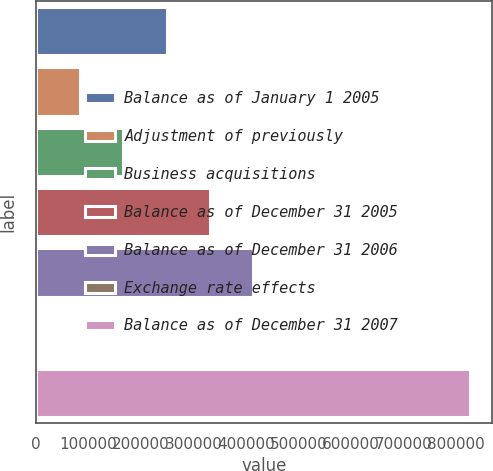Convert chart. <chart><loc_0><loc_0><loc_500><loc_500><bar_chart><fcel>Balance as of January 1 2005<fcel>Adjustment of previously<fcel>Business acquisitions<fcel>Balance as of December 31 2005<fcel>Balance as of December 31 2006<fcel>Exchange rate effects<fcel>Balance as of December 31 2007<nl><fcel>248746<fcel>83850.8<fcel>166299<fcel>331194<fcel>413642<fcel>1403<fcel>825881<nl></chart> 